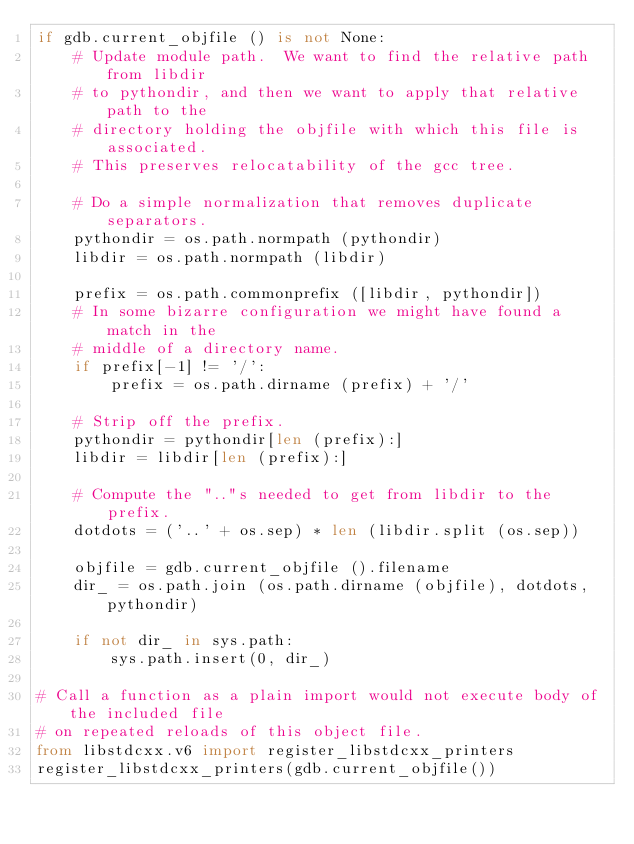Convert code to text. <code><loc_0><loc_0><loc_500><loc_500><_Python_>if gdb.current_objfile () is not None:
    # Update module path.  We want to find the relative path from libdir
    # to pythondir, and then we want to apply that relative path to the
    # directory holding the objfile with which this file is associated.
    # This preserves relocatability of the gcc tree.

    # Do a simple normalization that removes duplicate separators.
    pythondir = os.path.normpath (pythondir)
    libdir = os.path.normpath (libdir)

    prefix = os.path.commonprefix ([libdir, pythondir])
    # In some bizarre configuration we might have found a match in the
    # middle of a directory name.
    if prefix[-1] != '/':
        prefix = os.path.dirname (prefix) + '/'

    # Strip off the prefix.
    pythondir = pythondir[len (prefix):]
    libdir = libdir[len (prefix):]

    # Compute the ".."s needed to get from libdir to the prefix.
    dotdots = ('..' + os.sep) * len (libdir.split (os.sep))

    objfile = gdb.current_objfile ().filename
    dir_ = os.path.join (os.path.dirname (objfile), dotdots, pythondir)

    if not dir_ in sys.path:
        sys.path.insert(0, dir_)

# Call a function as a plain import would not execute body of the included file
# on repeated reloads of this object file.
from libstdcxx.v6 import register_libstdcxx_printers
register_libstdcxx_printers(gdb.current_objfile())
</code> 